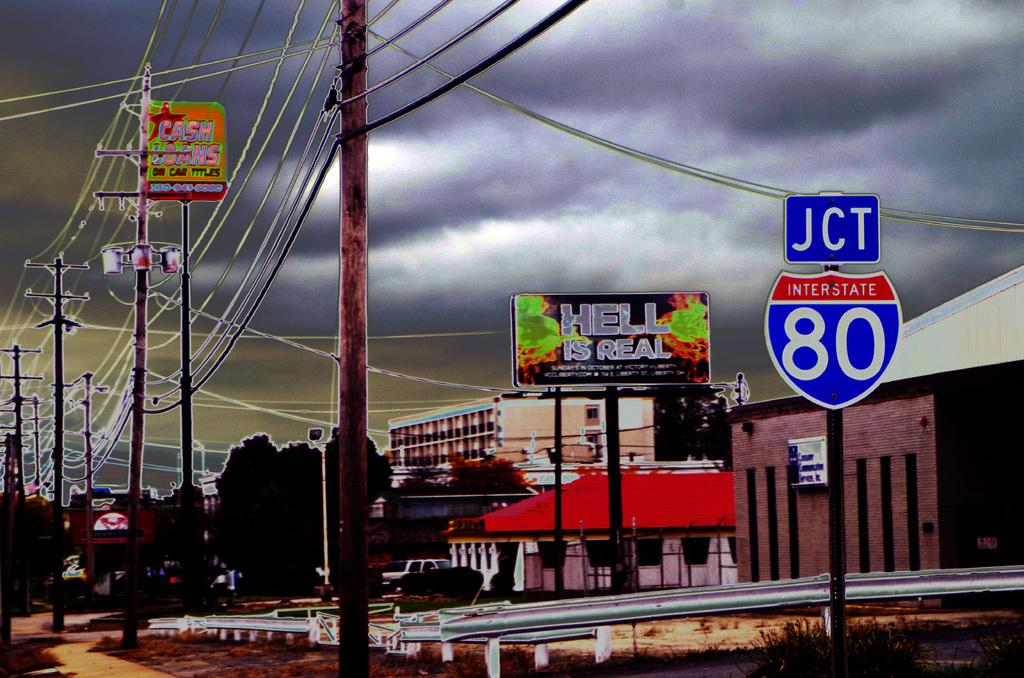<image>
Create a compact narrative representing the image presented. JCT Interstate 80 displaying a sign stating Hell is real 